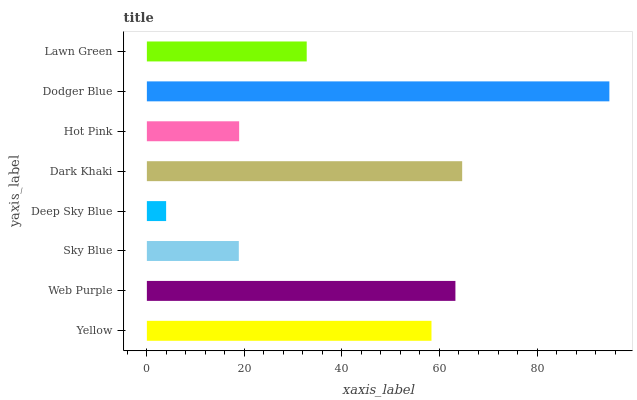Is Deep Sky Blue the minimum?
Answer yes or no. Yes. Is Dodger Blue the maximum?
Answer yes or no. Yes. Is Web Purple the minimum?
Answer yes or no. No. Is Web Purple the maximum?
Answer yes or no. No. Is Web Purple greater than Yellow?
Answer yes or no. Yes. Is Yellow less than Web Purple?
Answer yes or no. Yes. Is Yellow greater than Web Purple?
Answer yes or no. No. Is Web Purple less than Yellow?
Answer yes or no. No. Is Yellow the high median?
Answer yes or no. Yes. Is Lawn Green the low median?
Answer yes or no. Yes. Is Sky Blue the high median?
Answer yes or no. No. Is Web Purple the low median?
Answer yes or no. No. 